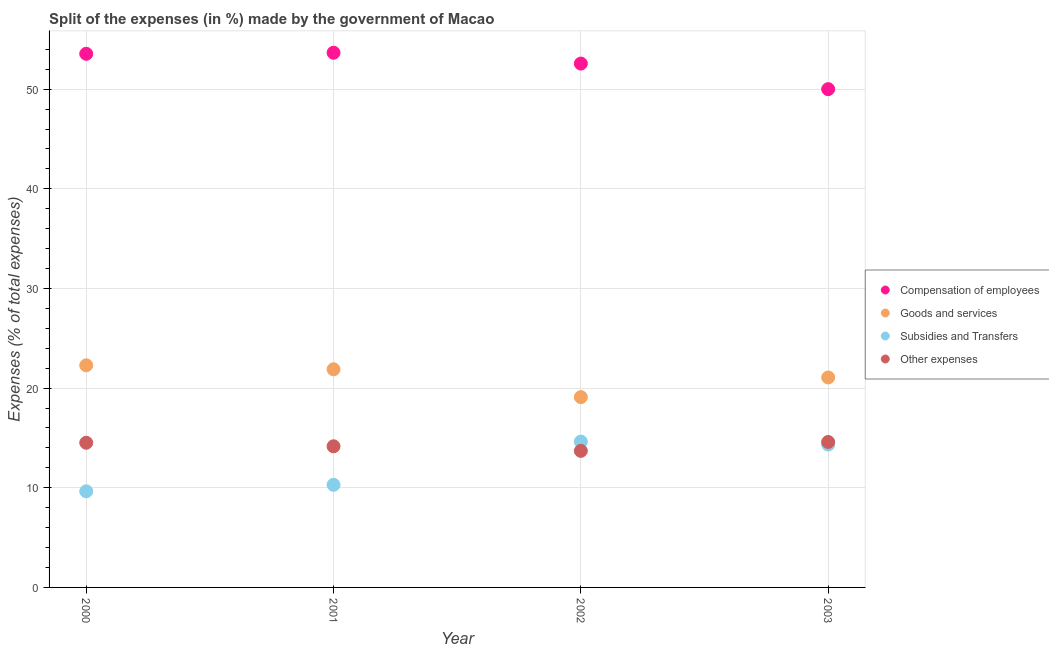How many different coloured dotlines are there?
Ensure brevity in your answer.  4. Is the number of dotlines equal to the number of legend labels?
Ensure brevity in your answer.  Yes. What is the percentage of amount spent on other expenses in 2002?
Provide a short and direct response. 13.7. Across all years, what is the maximum percentage of amount spent on compensation of employees?
Keep it short and to the point. 53.65. Across all years, what is the minimum percentage of amount spent on goods and services?
Offer a very short reply. 19.09. In which year was the percentage of amount spent on goods and services maximum?
Offer a very short reply. 2000. What is the total percentage of amount spent on other expenses in the graph?
Give a very brief answer. 56.98. What is the difference between the percentage of amount spent on compensation of employees in 2002 and that in 2003?
Ensure brevity in your answer.  2.57. What is the difference between the percentage of amount spent on goods and services in 2001 and the percentage of amount spent on subsidies in 2002?
Provide a succinct answer. 7.25. What is the average percentage of amount spent on compensation of employees per year?
Your response must be concise. 52.44. In the year 2002, what is the difference between the percentage of amount spent on other expenses and percentage of amount spent on goods and services?
Ensure brevity in your answer.  -5.39. In how many years, is the percentage of amount spent on other expenses greater than 4 %?
Make the answer very short. 4. What is the ratio of the percentage of amount spent on other expenses in 2000 to that in 2002?
Your answer should be very brief. 1.06. Is the difference between the percentage of amount spent on compensation of employees in 2002 and 2003 greater than the difference between the percentage of amount spent on goods and services in 2002 and 2003?
Make the answer very short. Yes. What is the difference between the highest and the second highest percentage of amount spent on goods and services?
Provide a succinct answer. 0.4. What is the difference between the highest and the lowest percentage of amount spent on goods and services?
Offer a terse response. 3.19. In how many years, is the percentage of amount spent on other expenses greater than the average percentage of amount spent on other expenses taken over all years?
Your answer should be compact. 2. Is it the case that in every year, the sum of the percentage of amount spent on compensation of employees and percentage of amount spent on goods and services is greater than the percentage of amount spent on subsidies?
Your answer should be compact. Yes. Is the percentage of amount spent on compensation of employees strictly less than the percentage of amount spent on other expenses over the years?
Make the answer very short. No. How many dotlines are there?
Provide a succinct answer. 4. Are the values on the major ticks of Y-axis written in scientific E-notation?
Provide a short and direct response. No. How many legend labels are there?
Provide a succinct answer. 4. What is the title of the graph?
Ensure brevity in your answer.  Split of the expenses (in %) made by the government of Macao. Does "Business regulatory environment" appear as one of the legend labels in the graph?
Keep it short and to the point. No. What is the label or title of the X-axis?
Ensure brevity in your answer.  Year. What is the label or title of the Y-axis?
Keep it short and to the point. Expenses (% of total expenses). What is the Expenses (% of total expenses) of Compensation of employees in 2000?
Provide a succinct answer. 53.55. What is the Expenses (% of total expenses) of Goods and services in 2000?
Offer a terse response. 22.29. What is the Expenses (% of total expenses) of Subsidies and Transfers in 2000?
Your answer should be compact. 9.65. What is the Expenses (% of total expenses) of Other expenses in 2000?
Provide a succinct answer. 14.52. What is the Expenses (% of total expenses) in Compensation of employees in 2001?
Keep it short and to the point. 53.65. What is the Expenses (% of total expenses) of Goods and services in 2001?
Your response must be concise. 21.89. What is the Expenses (% of total expenses) of Subsidies and Transfers in 2001?
Make the answer very short. 10.3. What is the Expenses (% of total expenses) in Other expenses in 2001?
Offer a terse response. 14.16. What is the Expenses (% of total expenses) of Compensation of employees in 2002?
Provide a succinct answer. 52.57. What is the Expenses (% of total expenses) in Goods and services in 2002?
Provide a succinct answer. 19.09. What is the Expenses (% of total expenses) of Subsidies and Transfers in 2002?
Keep it short and to the point. 14.63. What is the Expenses (% of total expenses) in Other expenses in 2002?
Give a very brief answer. 13.7. What is the Expenses (% of total expenses) in Compensation of employees in 2003?
Offer a terse response. 50. What is the Expenses (% of total expenses) of Goods and services in 2003?
Provide a succinct answer. 21.07. What is the Expenses (% of total expenses) of Subsidies and Transfers in 2003?
Give a very brief answer. 14.33. What is the Expenses (% of total expenses) of Other expenses in 2003?
Provide a succinct answer. 14.6. Across all years, what is the maximum Expenses (% of total expenses) in Compensation of employees?
Your response must be concise. 53.65. Across all years, what is the maximum Expenses (% of total expenses) in Goods and services?
Provide a succinct answer. 22.29. Across all years, what is the maximum Expenses (% of total expenses) of Subsidies and Transfers?
Provide a succinct answer. 14.63. Across all years, what is the maximum Expenses (% of total expenses) in Other expenses?
Keep it short and to the point. 14.6. Across all years, what is the minimum Expenses (% of total expenses) in Compensation of employees?
Give a very brief answer. 50. Across all years, what is the minimum Expenses (% of total expenses) in Goods and services?
Keep it short and to the point. 19.09. Across all years, what is the minimum Expenses (% of total expenses) of Subsidies and Transfers?
Make the answer very short. 9.65. Across all years, what is the minimum Expenses (% of total expenses) in Other expenses?
Offer a terse response. 13.7. What is the total Expenses (% of total expenses) of Compensation of employees in the graph?
Keep it short and to the point. 209.77. What is the total Expenses (% of total expenses) in Goods and services in the graph?
Your answer should be compact. 84.34. What is the total Expenses (% of total expenses) of Subsidies and Transfers in the graph?
Give a very brief answer. 48.91. What is the total Expenses (% of total expenses) of Other expenses in the graph?
Offer a terse response. 56.98. What is the difference between the Expenses (% of total expenses) in Compensation of employees in 2000 and that in 2001?
Provide a short and direct response. -0.1. What is the difference between the Expenses (% of total expenses) in Goods and services in 2000 and that in 2001?
Your response must be concise. 0.4. What is the difference between the Expenses (% of total expenses) in Subsidies and Transfers in 2000 and that in 2001?
Ensure brevity in your answer.  -0.65. What is the difference between the Expenses (% of total expenses) in Other expenses in 2000 and that in 2001?
Your answer should be very brief. 0.36. What is the difference between the Expenses (% of total expenses) in Compensation of employees in 2000 and that in 2002?
Your response must be concise. 0.98. What is the difference between the Expenses (% of total expenses) in Goods and services in 2000 and that in 2002?
Provide a succinct answer. 3.19. What is the difference between the Expenses (% of total expenses) in Subsidies and Transfers in 2000 and that in 2002?
Give a very brief answer. -4.99. What is the difference between the Expenses (% of total expenses) in Other expenses in 2000 and that in 2002?
Ensure brevity in your answer.  0.81. What is the difference between the Expenses (% of total expenses) in Compensation of employees in 2000 and that in 2003?
Make the answer very short. 3.55. What is the difference between the Expenses (% of total expenses) of Goods and services in 2000 and that in 2003?
Make the answer very short. 1.22. What is the difference between the Expenses (% of total expenses) in Subsidies and Transfers in 2000 and that in 2003?
Your answer should be compact. -4.69. What is the difference between the Expenses (% of total expenses) of Other expenses in 2000 and that in 2003?
Your answer should be very brief. -0.08. What is the difference between the Expenses (% of total expenses) of Compensation of employees in 2001 and that in 2002?
Keep it short and to the point. 1.08. What is the difference between the Expenses (% of total expenses) in Goods and services in 2001 and that in 2002?
Make the answer very short. 2.8. What is the difference between the Expenses (% of total expenses) of Subsidies and Transfers in 2001 and that in 2002?
Offer a very short reply. -4.34. What is the difference between the Expenses (% of total expenses) in Other expenses in 2001 and that in 2002?
Keep it short and to the point. 0.46. What is the difference between the Expenses (% of total expenses) in Compensation of employees in 2001 and that in 2003?
Keep it short and to the point. 3.65. What is the difference between the Expenses (% of total expenses) of Goods and services in 2001 and that in 2003?
Provide a short and direct response. 0.82. What is the difference between the Expenses (% of total expenses) of Subsidies and Transfers in 2001 and that in 2003?
Provide a succinct answer. -4.04. What is the difference between the Expenses (% of total expenses) in Other expenses in 2001 and that in 2003?
Offer a terse response. -0.43. What is the difference between the Expenses (% of total expenses) in Compensation of employees in 2002 and that in 2003?
Your answer should be very brief. 2.57. What is the difference between the Expenses (% of total expenses) of Goods and services in 2002 and that in 2003?
Give a very brief answer. -1.98. What is the difference between the Expenses (% of total expenses) in Subsidies and Transfers in 2002 and that in 2003?
Make the answer very short. 0.3. What is the difference between the Expenses (% of total expenses) of Other expenses in 2002 and that in 2003?
Provide a succinct answer. -0.89. What is the difference between the Expenses (% of total expenses) in Compensation of employees in 2000 and the Expenses (% of total expenses) in Goods and services in 2001?
Give a very brief answer. 31.66. What is the difference between the Expenses (% of total expenses) in Compensation of employees in 2000 and the Expenses (% of total expenses) in Subsidies and Transfers in 2001?
Offer a terse response. 43.25. What is the difference between the Expenses (% of total expenses) of Compensation of employees in 2000 and the Expenses (% of total expenses) of Other expenses in 2001?
Make the answer very short. 39.39. What is the difference between the Expenses (% of total expenses) of Goods and services in 2000 and the Expenses (% of total expenses) of Subsidies and Transfers in 2001?
Provide a succinct answer. 11.99. What is the difference between the Expenses (% of total expenses) in Goods and services in 2000 and the Expenses (% of total expenses) in Other expenses in 2001?
Make the answer very short. 8.13. What is the difference between the Expenses (% of total expenses) of Subsidies and Transfers in 2000 and the Expenses (% of total expenses) of Other expenses in 2001?
Make the answer very short. -4.52. What is the difference between the Expenses (% of total expenses) in Compensation of employees in 2000 and the Expenses (% of total expenses) in Goods and services in 2002?
Provide a short and direct response. 34.45. What is the difference between the Expenses (% of total expenses) of Compensation of employees in 2000 and the Expenses (% of total expenses) of Subsidies and Transfers in 2002?
Provide a short and direct response. 38.91. What is the difference between the Expenses (% of total expenses) of Compensation of employees in 2000 and the Expenses (% of total expenses) of Other expenses in 2002?
Offer a very short reply. 39.84. What is the difference between the Expenses (% of total expenses) of Goods and services in 2000 and the Expenses (% of total expenses) of Subsidies and Transfers in 2002?
Keep it short and to the point. 7.65. What is the difference between the Expenses (% of total expenses) of Goods and services in 2000 and the Expenses (% of total expenses) of Other expenses in 2002?
Provide a short and direct response. 8.58. What is the difference between the Expenses (% of total expenses) in Subsidies and Transfers in 2000 and the Expenses (% of total expenses) in Other expenses in 2002?
Your response must be concise. -4.06. What is the difference between the Expenses (% of total expenses) of Compensation of employees in 2000 and the Expenses (% of total expenses) of Goods and services in 2003?
Your answer should be very brief. 32.48. What is the difference between the Expenses (% of total expenses) in Compensation of employees in 2000 and the Expenses (% of total expenses) in Subsidies and Transfers in 2003?
Your answer should be compact. 39.21. What is the difference between the Expenses (% of total expenses) of Compensation of employees in 2000 and the Expenses (% of total expenses) of Other expenses in 2003?
Your answer should be compact. 38.95. What is the difference between the Expenses (% of total expenses) in Goods and services in 2000 and the Expenses (% of total expenses) in Subsidies and Transfers in 2003?
Your answer should be very brief. 7.95. What is the difference between the Expenses (% of total expenses) of Goods and services in 2000 and the Expenses (% of total expenses) of Other expenses in 2003?
Provide a succinct answer. 7.69. What is the difference between the Expenses (% of total expenses) of Subsidies and Transfers in 2000 and the Expenses (% of total expenses) of Other expenses in 2003?
Provide a succinct answer. -4.95. What is the difference between the Expenses (% of total expenses) in Compensation of employees in 2001 and the Expenses (% of total expenses) in Goods and services in 2002?
Offer a very short reply. 34.56. What is the difference between the Expenses (% of total expenses) in Compensation of employees in 2001 and the Expenses (% of total expenses) in Subsidies and Transfers in 2002?
Keep it short and to the point. 39.02. What is the difference between the Expenses (% of total expenses) of Compensation of employees in 2001 and the Expenses (% of total expenses) of Other expenses in 2002?
Make the answer very short. 39.95. What is the difference between the Expenses (% of total expenses) of Goods and services in 2001 and the Expenses (% of total expenses) of Subsidies and Transfers in 2002?
Your answer should be compact. 7.25. What is the difference between the Expenses (% of total expenses) of Goods and services in 2001 and the Expenses (% of total expenses) of Other expenses in 2002?
Offer a very short reply. 8.19. What is the difference between the Expenses (% of total expenses) of Subsidies and Transfers in 2001 and the Expenses (% of total expenses) of Other expenses in 2002?
Give a very brief answer. -3.41. What is the difference between the Expenses (% of total expenses) of Compensation of employees in 2001 and the Expenses (% of total expenses) of Goods and services in 2003?
Ensure brevity in your answer.  32.58. What is the difference between the Expenses (% of total expenses) in Compensation of employees in 2001 and the Expenses (% of total expenses) in Subsidies and Transfers in 2003?
Keep it short and to the point. 39.32. What is the difference between the Expenses (% of total expenses) of Compensation of employees in 2001 and the Expenses (% of total expenses) of Other expenses in 2003?
Offer a very short reply. 39.06. What is the difference between the Expenses (% of total expenses) in Goods and services in 2001 and the Expenses (% of total expenses) in Subsidies and Transfers in 2003?
Provide a succinct answer. 7.56. What is the difference between the Expenses (% of total expenses) of Goods and services in 2001 and the Expenses (% of total expenses) of Other expenses in 2003?
Make the answer very short. 7.29. What is the difference between the Expenses (% of total expenses) in Subsidies and Transfers in 2001 and the Expenses (% of total expenses) in Other expenses in 2003?
Your answer should be compact. -4.3. What is the difference between the Expenses (% of total expenses) in Compensation of employees in 2002 and the Expenses (% of total expenses) in Goods and services in 2003?
Ensure brevity in your answer.  31.5. What is the difference between the Expenses (% of total expenses) of Compensation of employees in 2002 and the Expenses (% of total expenses) of Subsidies and Transfers in 2003?
Provide a succinct answer. 38.23. What is the difference between the Expenses (% of total expenses) in Compensation of employees in 2002 and the Expenses (% of total expenses) in Other expenses in 2003?
Your response must be concise. 37.97. What is the difference between the Expenses (% of total expenses) of Goods and services in 2002 and the Expenses (% of total expenses) of Subsidies and Transfers in 2003?
Give a very brief answer. 4.76. What is the difference between the Expenses (% of total expenses) in Goods and services in 2002 and the Expenses (% of total expenses) in Other expenses in 2003?
Offer a very short reply. 4.5. What is the difference between the Expenses (% of total expenses) of Subsidies and Transfers in 2002 and the Expenses (% of total expenses) of Other expenses in 2003?
Keep it short and to the point. 0.04. What is the average Expenses (% of total expenses) in Compensation of employees per year?
Make the answer very short. 52.44. What is the average Expenses (% of total expenses) of Goods and services per year?
Give a very brief answer. 21.09. What is the average Expenses (% of total expenses) of Subsidies and Transfers per year?
Give a very brief answer. 12.23. What is the average Expenses (% of total expenses) in Other expenses per year?
Your response must be concise. 14.24. In the year 2000, what is the difference between the Expenses (% of total expenses) in Compensation of employees and Expenses (% of total expenses) in Goods and services?
Your answer should be compact. 31.26. In the year 2000, what is the difference between the Expenses (% of total expenses) of Compensation of employees and Expenses (% of total expenses) of Subsidies and Transfers?
Give a very brief answer. 43.9. In the year 2000, what is the difference between the Expenses (% of total expenses) in Compensation of employees and Expenses (% of total expenses) in Other expenses?
Offer a terse response. 39.03. In the year 2000, what is the difference between the Expenses (% of total expenses) in Goods and services and Expenses (% of total expenses) in Subsidies and Transfers?
Keep it short and to the point. 12.64. In the year 2000, what is the difference between the Expenses (% of total expenses) in Goods and services and Expenses (% of total expenses) in Other expenses?
Offer a terse response. 7.77. In the year 2000, what is the difference between the Expenses (% of total expenses) of Subsidies and Transfers and Expenses (% of total expenses) of Other expenses?
Your response must be concise. -4.87. In the year 2001, what is the difference between the Expenses (% of total expenses) in Compensation of employees and Expenses (% of total expenses) in Goods and services?
Give a very brief answer. 31.76. In the year 2001, what is the difference between the Expenses (% of total expenses) in Compensation of employees and Expenses (% of total expenses) in Subsidies and Transfers?
Offer a terse response. 43.36. In the year 2001, what is the difference between the Expenses (% of total expenses) of Compensation of employees and Expenses (% of total expenses) of Other expenses?
Provide a short and direct response. 39.49. In the year 2001, what is the difference between the Expenses (% of total expenses) in Goods and services and Expenses (% of total expenses) in Subsidies and Transfers?
Provide a short and direct response. 11.59. In the year 2001, what is the difference between the Expenses (% of total expenses) of Goods and services and Expenses (% of total expenses) of Other expenses?
Keep it short and to the point. 7.73. In the year 2001, what is the difference between the Expenses (% of total expenses) in Subsidies and Transfers and Expenses (% of total expenses) in Other expenses?
Keep it short and to the point. -3.87. In the year 2002, what is the difference between the Expenses (% of total expenses) of Compensation of employees and Expenses (% of total expenses) of Goods and services?
Your answer should be very brief. 33.48. In the year 2002, what is the difference between the Expenses (% of total expenses) of Compensation of employees and Expenses (% of total expenses) of Subsidies and Transfers?
Your answer should be very brief. 37.93. In the year 2002, what is the difference between the Expenses (% of total expenses) in Compensation of employees and Expenses (% of total expenses) in Other expenses?
Your response must be concise. 38.87. In the year 2002, what is the difference between the Expenses (% of total expenses) of Goods and services and Expenses (% of total expenses) of Subsidies and Transfers?
Offer a terse response. 4.46. In the year 2002, what is the difference between the Expenses (% of total expenses) of Goods and services and Expenses (% of total expenses) of Other expenses?
Offer a very short reply. 5.39. In the year 2002, what is the difference between the Expenses (% of total expenses) in Subsidies and Transfers and Expenses (% of total expenses) in Other expenses?
Offer a very short reply. 0.93. In the year 2003, what is the difference between the Expenses (% of total expenses) of Compensation of employees and Expenses (% of total expenses) of Goods and services?
Your response must be concise. 28.93. In the year 2003, what is the difference between the Expenses (% of total expenses) in Compensation of employees and Expenses (% of total expenses) in Subsidies and Transfers?
Your answer should be very brief. 35.67. In the year 2003, what is the difference between the Expenses (% of total expenses) in Compensation of employees and Expenses (% of total expenses) in Other expenses?
Keep it short and to the point. 35.4. In the year 2003, what is the difference between the Expenses (% of total expenses) in Goods and services and Expenses (% of total expenses) in Subsidies and Transfers?
Provide a short and direct response. 6.74. In the year 2003, what is the difference between the Expenses (% of total expenses) of Goods and services and Expenses (% of total expenses) of Other expenses?
Your response must be concise. 6.47. In the year 2003, what is the difference between the Expenses (% of total expenses) in Subsidies and Transfers and Expenses (% of total expenses) in Other expenses?
Provide a short and direct response. -0.26. What is the ratio of the Expenses (% of total expenses) in Compensation of employees in 2000 to that in 2001?
Ensure brevity in your answer.  1. What is the ratio of the Expenses (% of total expenses) in Goods and services in 2000 to that in 2001?
Provide a short and direct response. 1.02. What is the ratio of the Expenses (% of total expenses) in Subsidies and Transfers in 2000 to that in 2001?
Your answer should be very brief. 0.94. What is the ratio of the Expenses (% of total expenses) in Other expenses in 2000 to that in 2001?
Provide a succinct answer. 1.03. What is the ratio of the Expenses (% of total expenses) in Compensation of employees in 2000 to that in 2002?
Your response must be concise. 1.02. What is the ratio of the Expenses (% of total expenses) in Goods and services in 2000 to that in 2002?
Make the answer very short. 1.17. What is the ratio of the Expenses (% of total expenses) in Subsidies and Transfers in 2000 to that in 2002?
Make the answer very short. 0.66. What is the ratio of the Expenses (% of total expenses) in Other expenses in 2000 to that in 2002?
Provide a succinct answer. 1.06. What is the ratio of the Expenses (% of total expenses) of Compensation of employees in 2000 to that in 2003?
Your answer should be very brief. 1.07. What is the ratio of the Expenses (% of total expenses) of Goods and services in 2000 to that in 2003?
Provide a short and direct response. 1.06. What is the ratio of the Expenses (% of total expenses) in Subsidies and Transfers in 2000 to that in 2003?
Your response must be concise. 0.67. What is the ratio of the Expenses (% of total expenses) of Compensation of employees in 2001 to that in 2002?
Ensure brevity in your answer.  1.02. What is the ratio of the Expenses (% of total expenses) in Goods and services in 2001 to that in 2002?
Ensure brevity in your answer.  1.15. What is the ratio of the Expenses (% of total expenses) in Subsidies and Transfers in 2001 to that in 2002?
Your response must be concise. 0.7. What is the ratio of the Expenses (% of total expenses) in Other expenses in 2001 to that in 2002?
Offer a very short reply. 1.03. What is the ratio of the Expenses (% of total expenses) of Compensation of employees in 2001 to that in 2003?
Your response must be concise. 1.07. What is the ratio of the Expenses (% of total expenses) in Goods and services in 2001 to that in 2003?
Keep it short and to the point. 1.04. What is the ratio of the Expenses (% of total expenses) in Subsidies and Transfers in 2001 to that in 2003?
Offer a terse response. 0.72. What is the ratio of the Expenses (% of total expenses) in Other expenses in 2001 to that in 2003?
Your response must be concise. 0.97. What is the ratio of the Expenses (% of total expenses) in Compensation of employees in 2002 to that in 2003?
Give a very brief answer. 1.05. What is the ratio of the Expenses (% of total expenses) in Goods and services in 2002 to that in 2003?
Your answer should be compact. 0.91. What is the ratio of the Expenses (% of total expenses) of Other expenses in 2002 to that in 2003?
Keep it short and to the point. 0.94. What is the difference between the highest and the second highest Expenses (% of total expenses) in Compensation of employees?
Your response must be concise. 0.1. What is the difference between the highest and the second highest Expenses (% of total expenses) of Goods and services?
Your answer should be very brief. 0.4. What is the difference between the highest and the second highest Expenses (% of total expenses) in Subsidies and Transfers?
Make the answer very short. 0.3. What is the difference between the highest and the second highest Expenses (% of total expenses) in Other expenses?
Your answer should be compact. 0.08. What is the difference between the highest and the lowest Expenses (% of total expenses) of Compensation of employees?
Provide a succinct answer. 3.65. What is the difference between the highest and the lowest Expenses (% of total expenses) of Goods and services?
Offer a very short reply. 3.19. What is the difference between the highest and the lowest Expenses (% of total expenses) of Subsidies and Transfers?
Provide a short and direct response. 4.99. What is the difference between the highest and the lowest Expenses (% of total expenses) in Other expenses?
Provide a short and direct response. 0.89. 